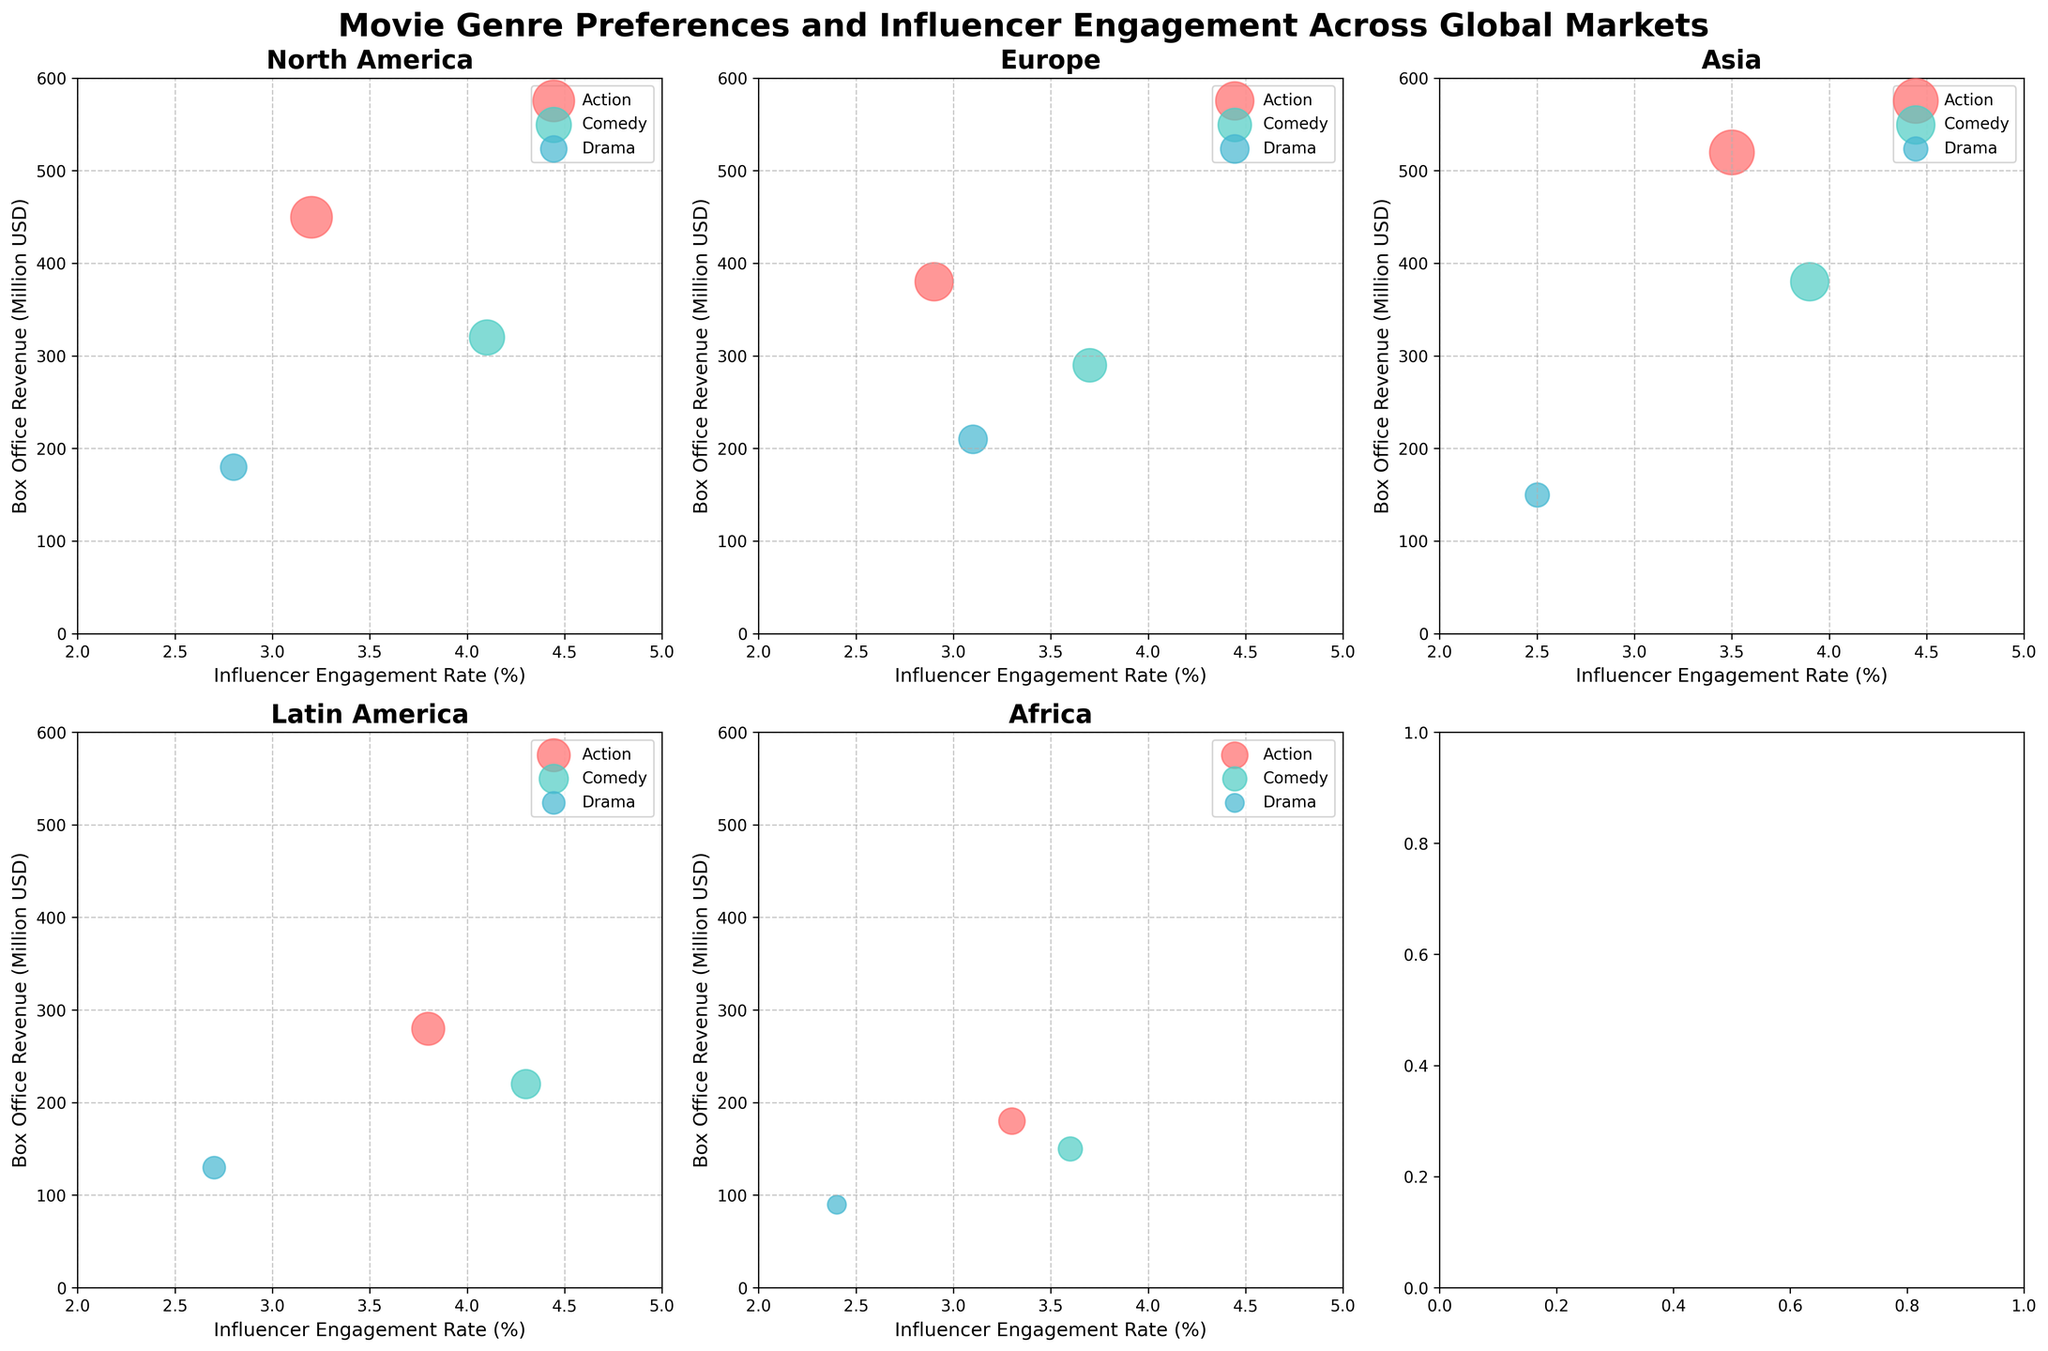How many markets are there in the subplot? To determine the number of markets, look at the subplot titles. Each subplot represents a different market, and there are six subplots in the figure.
Answer: Six Which genre has the highest influencer engagement rate in North America? Check the North America subplot and identify the genre with the highest value on the x-axis (Influencer Engagement Rate). Comedy has the highest value with 4.1%.
Answer: Comedy What's the total box office revenue for Action movies across all markets? Sum the box office revenues of Action movies:
(450 + 380 + 520 + 280 + 180) million USD. The individual amounts add up to 1810 million USD.
Answer: 1810 million USD Which market has the lowest box office revenue for Drama movies? Identify the Drama genre in each subplot and compare their values on the y-axis (Box Office Revenue). Africa has the lowest value with 90 million USD.
Answer: Africa Compare the influencer engagement rates of Comedy movies in Asia and Latin America. Which one is higher? Check the Comedy genre in both the Asia and Latin America subplots, then compare the x-axis values. Latin America (4.3%) is higher than Asia (3.9%).
Answer: Latin America Which market shows the widest range of box office revenues across genres? To find the market with the widest range, calculate the difference between the highest and lowest box office revenues for each market and compare. North America's range: 450 - 180 = 270; Europe: 380 - 210 = 170; Asia: 520 - 150 = 370; Latin America: 280 - 130 = 150; and Africa: 180 - 90 = 90. Asia has the widest range with a difference of 370 million USD.
Answer: Asia In which market does the Drama genre have a higher engagement rate than Comedy? Compare the engagement rates of Drama and Comedy genres within each subplot. Only in Europe does Drama (3.1%) have a rate lower than Comedy (3.7%), and in no market does Drama exceed Comedy.
Answer: None Which genre generally shows the highest box office revenue trends globally? Observe the trends across all subplots, noting which genre generally has bubbles positioned highest on the y-axis. Action movies consistently show the highest box office revenues globally.
Answer: Action What is the average influencer engagement rate for Comedy movies across all markets? Sum the engagement rates of Comedy movies for each market and divide by the number of markets: (4.1 + 3.7 + 3.9 + 4.3 + 3.6)/5 = 19.6/5 = 3.92%.
Answer: 3.92% In which market are the effects of influencer engagement on box office revenue most noticeable for Action movies? Observe the Action genre in each subplot and look for a correlation between influencer engagement rates (x-axis) and box office revenues (y-axis). Asia has the highest engagement rate (3.5%) and the highest box office revenue (520 million USD), indicating a strong effect.
Answer: Asia 